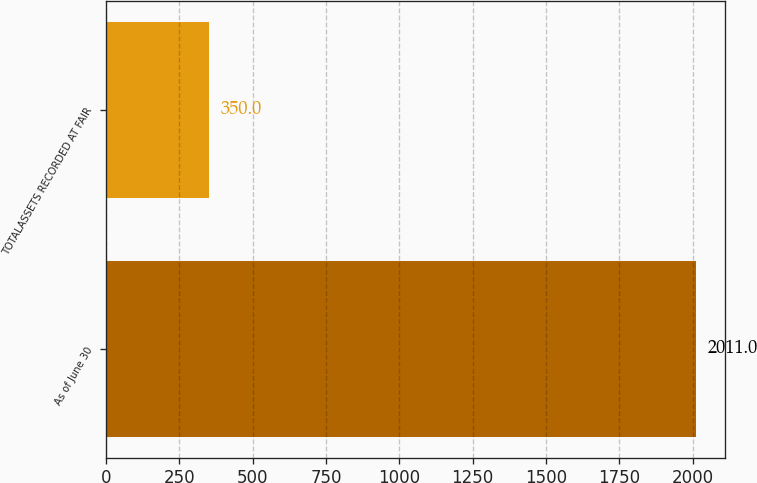<chart> <loc_0><loc_0><loc_500><loc_500><bar_chart><fcel>As of June 30<fcel>TOTALASSETS RECORDED AT FAIR<nl><fcel>2011<fcel>350<nl></chart> 